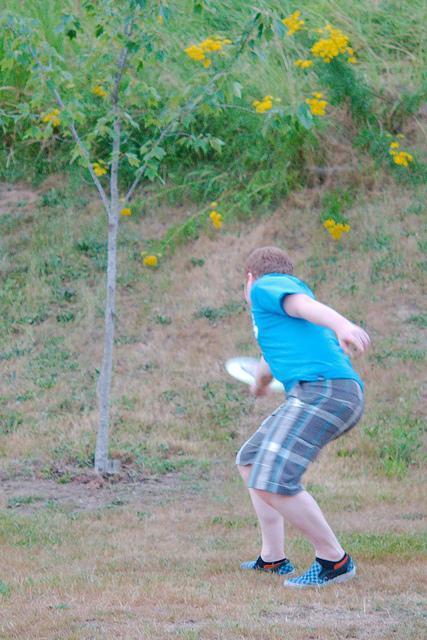How many trees are there?
Give a very brief answer. 1. 